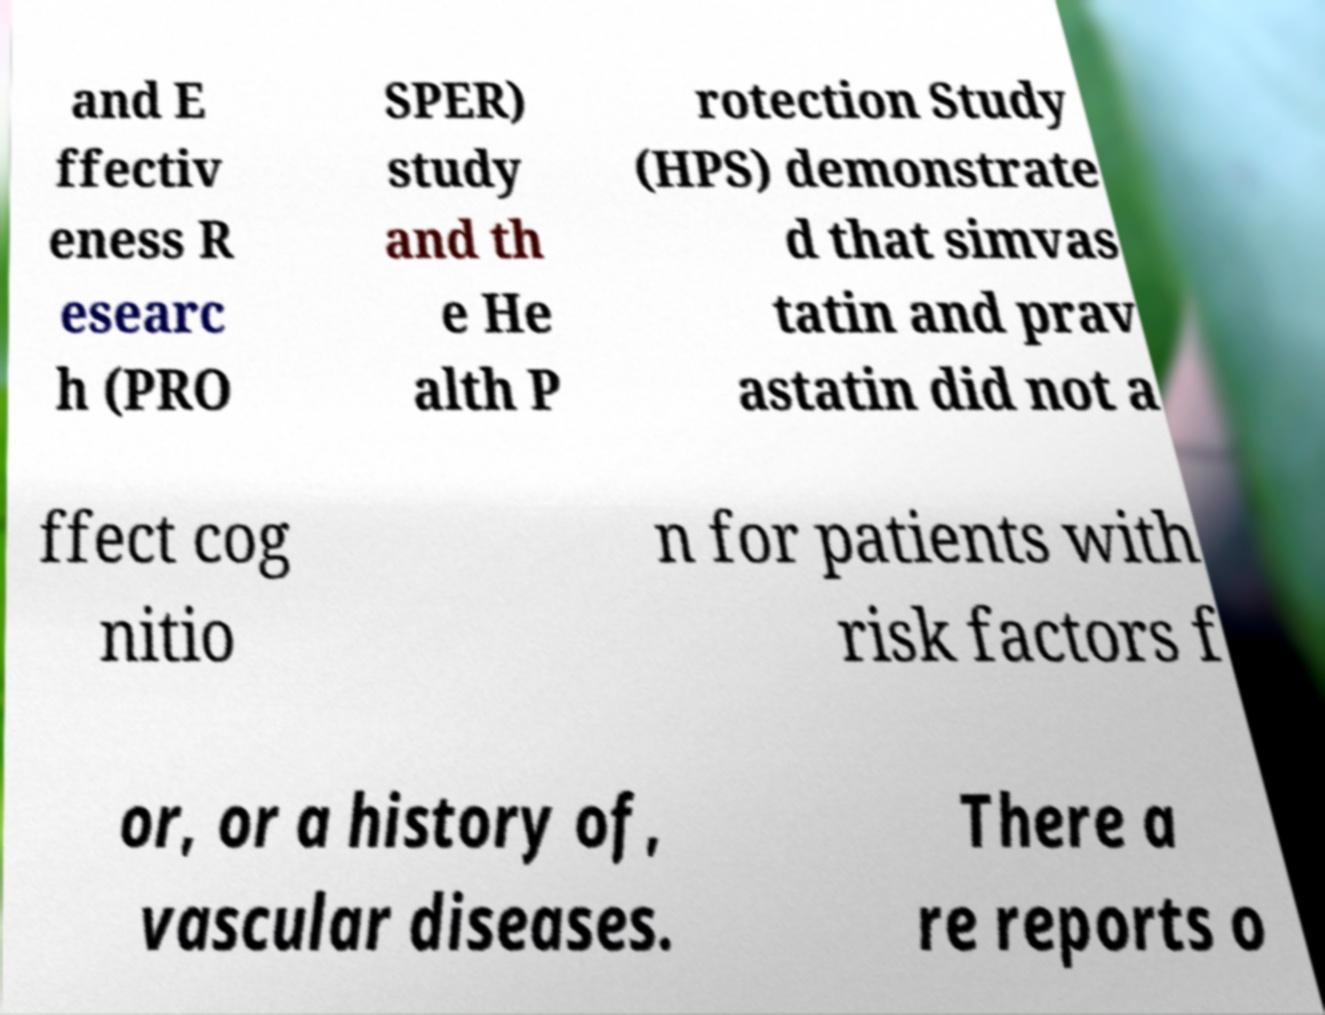Can you read and provide the text displayed in the image?This photo seems to have some interesting text. Can you extract and type it out for me? and E ffectiv eness R esearc h (PRO SPER) study and th e He alth P rotection Study (HPS) demonstrate d that simvas tatin and prav astatin did not a ffect cog nitio n for patients with risk factors f or, or a history of, vascular diseases. There a re reports o 